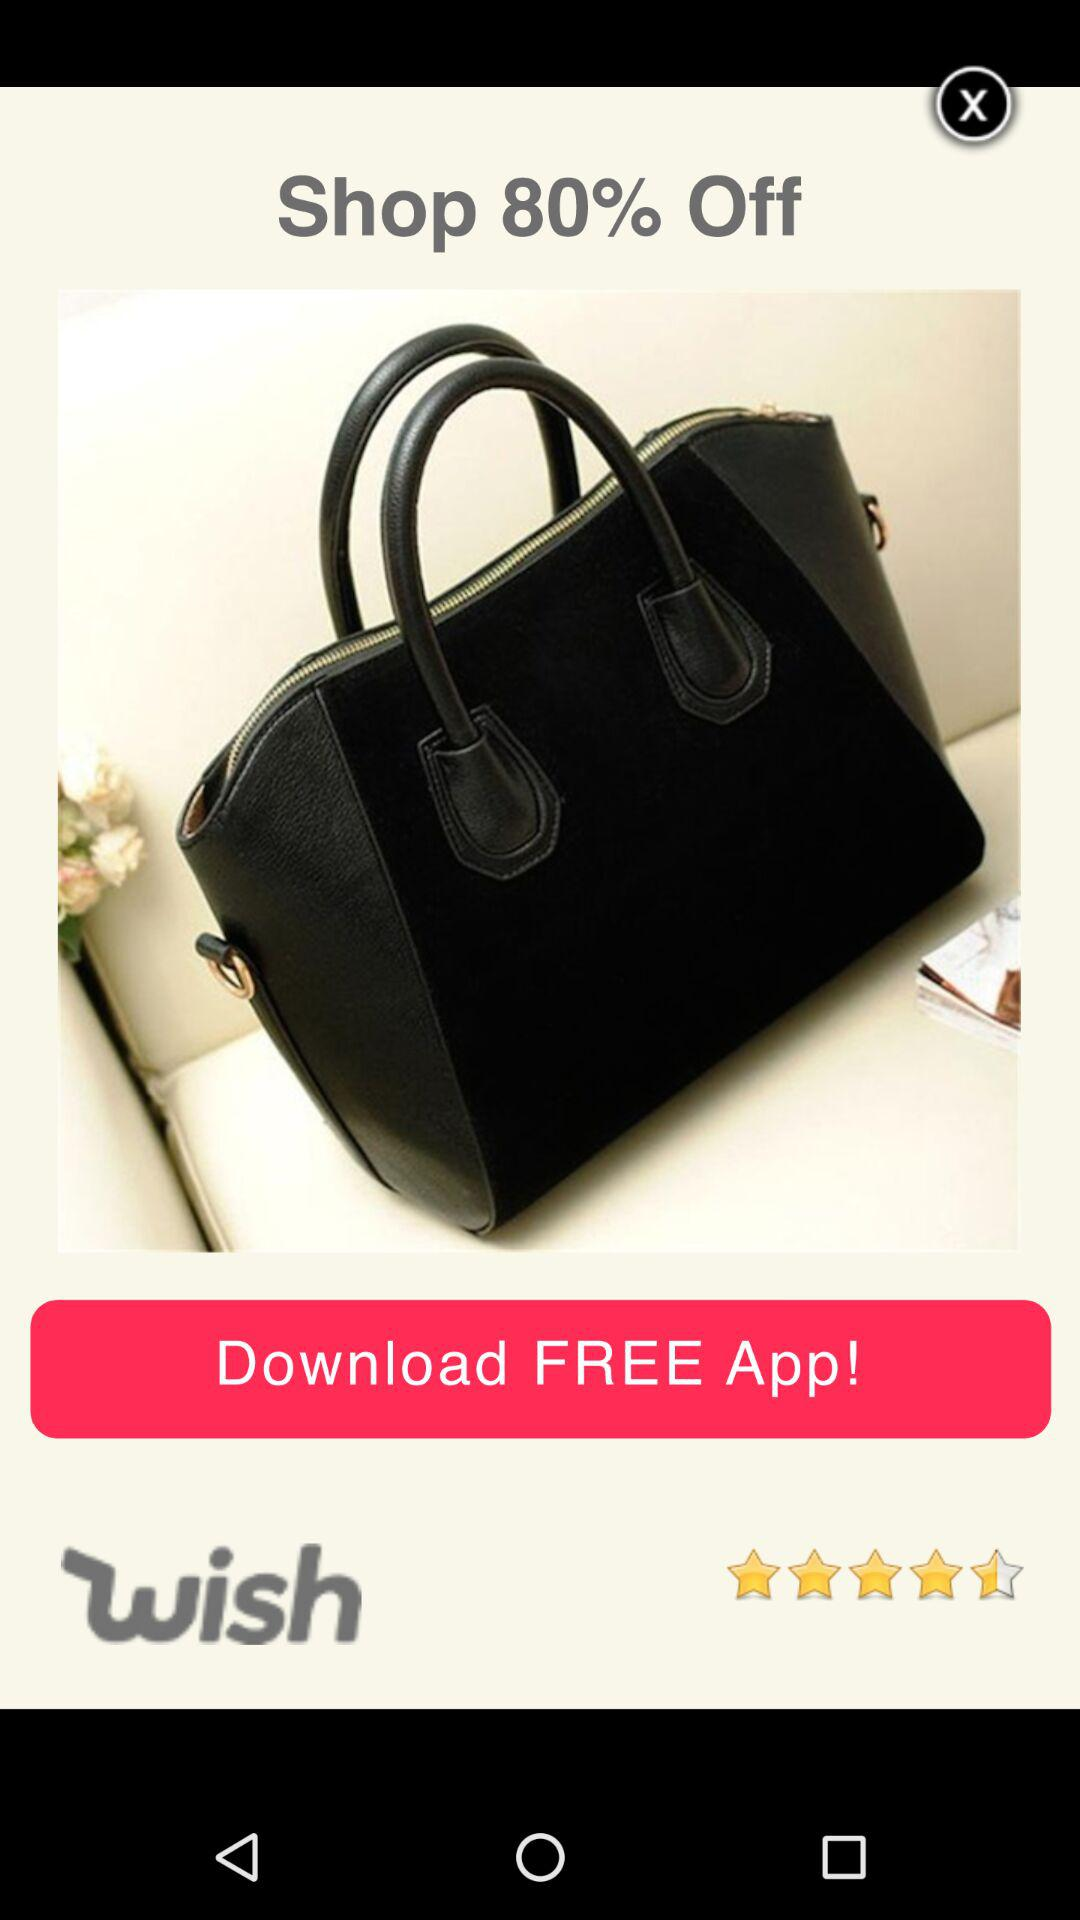How many percent off is the product?
Answer the question using a single word or phrase. 80% 